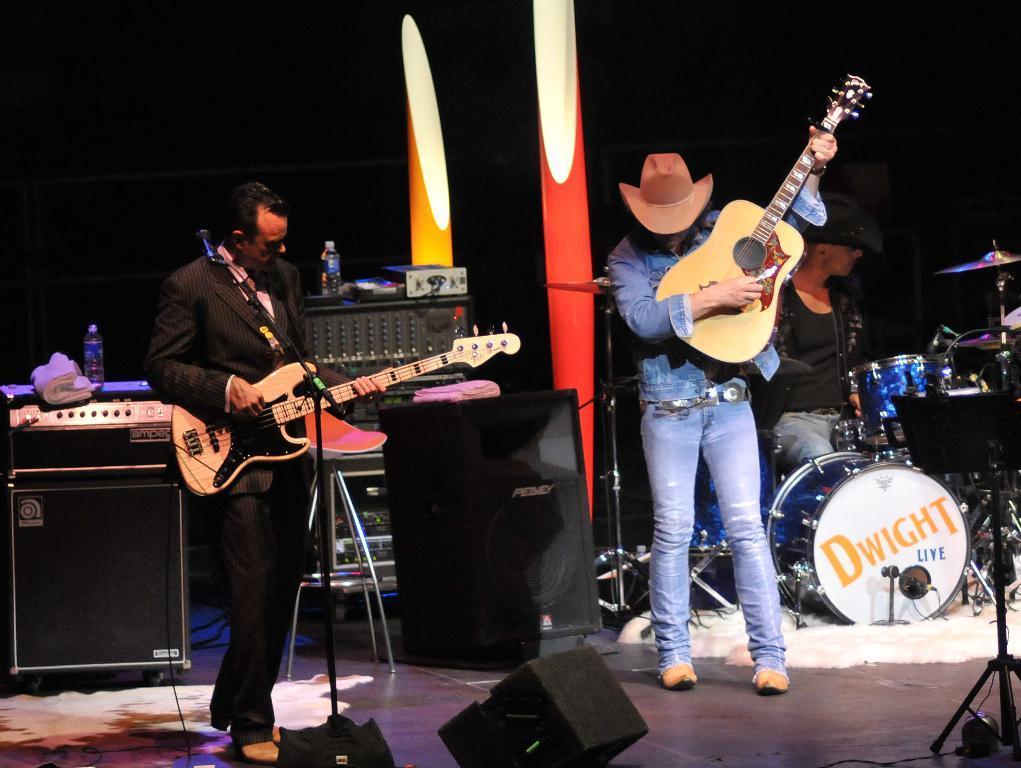Describe this image in one or two sentences. In this picture we can see two persons standing on stage here the person holding guitar in his hand playing and in front of him there is mic and on right side person same holding guitar and playing he wore hat and in background we can see bottles, speaker, light, drums, stand. 